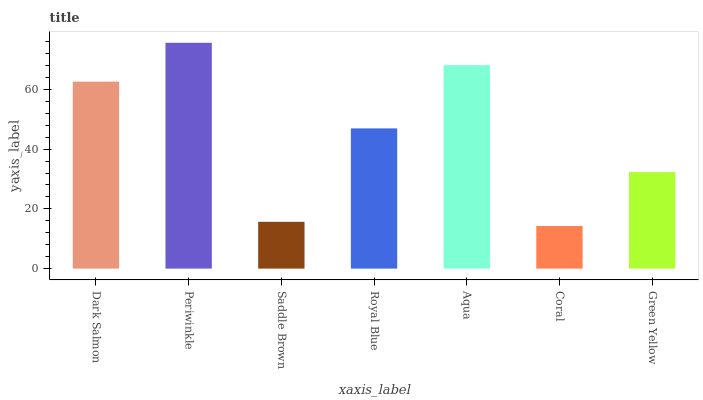Is Coral the minimum?
Answer yes or no. Yes. Is Periwinkle the maximum?
Answer yes or no. Yes. Is Saddle Brown the minimum?
Answer yes or no. No. Is Saddle Brown the maximum?
Answer yes or no. No. Is Periwinkle greater than Saddle Brown?
Answer yes or no. Yes. Is Saddle Brown less than Periwinkle?
Answer yes or no. Yes. Is Saddle Brown greater than Periwinkle?
Answer yes or no. No. Is Periwinkle less than Saddle Brown?
Answer yes or no. No. Is Royal Blue the high median?
Answer yes or no. Yes. Is Royal Blue the low median?
Answer yes or no. Yes. Is Saddle Brown the high median?
Answer yes or no. No. Is Periwinkle the low median?
Answer yes or no. No. 